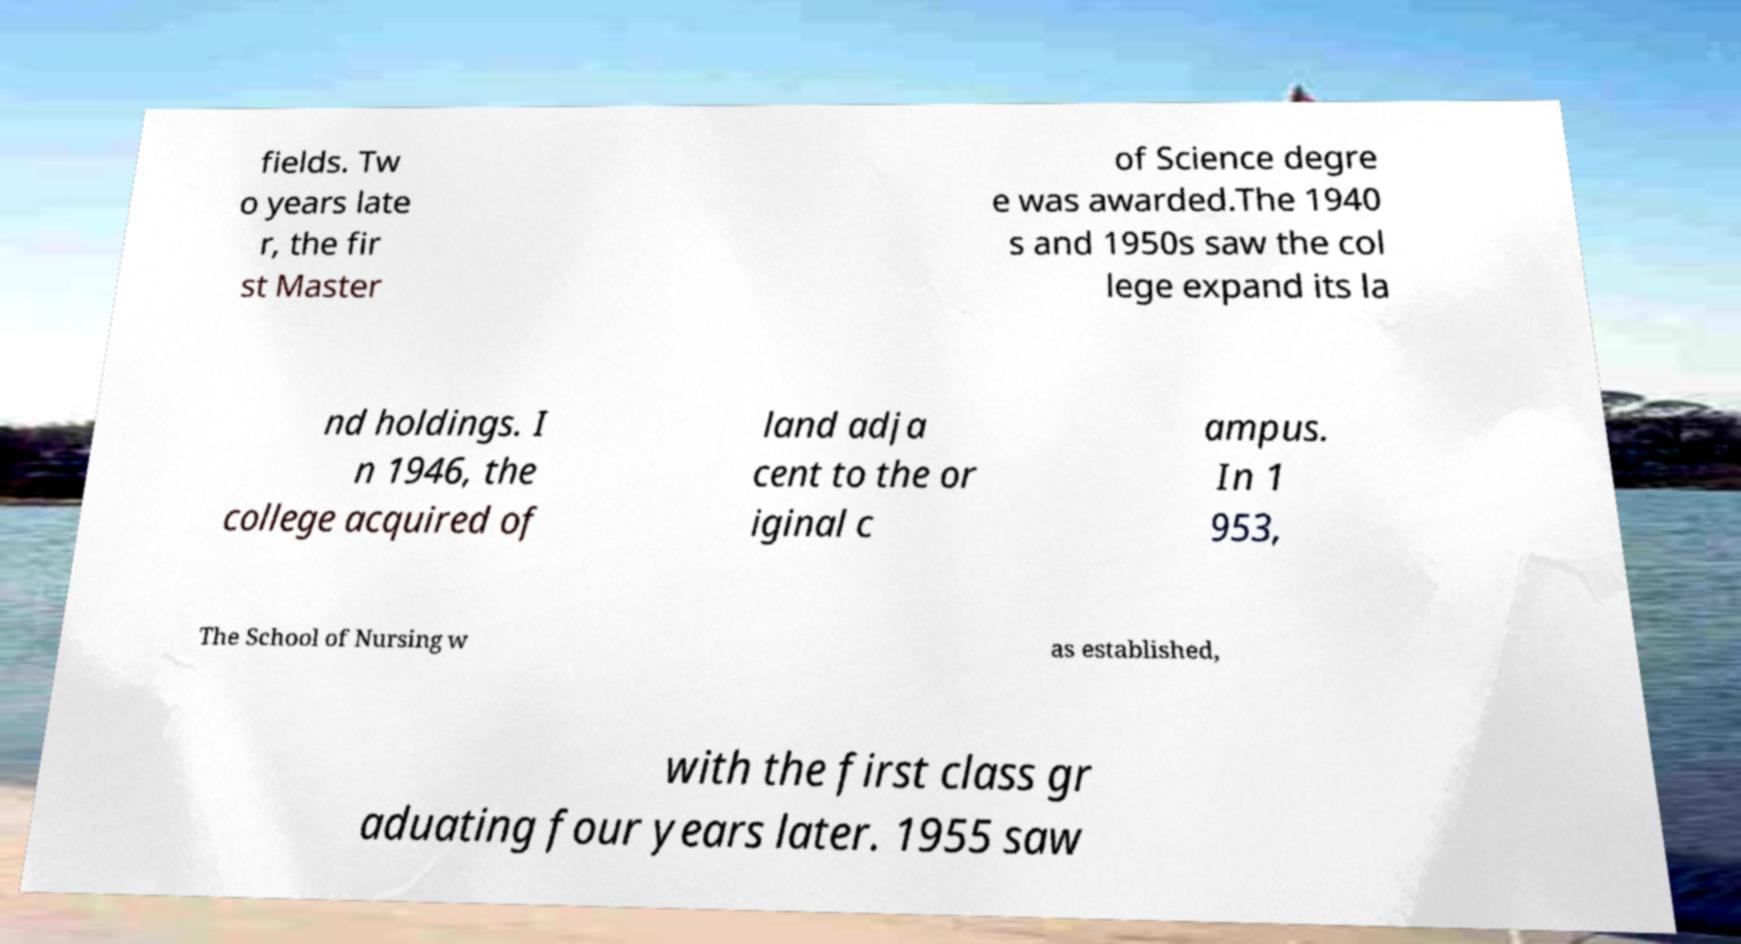What messages or text are displayed in this image? I need them in a readable, typed format. fields. Tw o years late r, the fir st Master of Science degre e was awarded.The 1940 s and 1950s saw the col lege expand its la nd holdings. I n 1946, the college acquired of land adja cent to the or iginal c ampus. In 1 953, The School of Nursing w as established, with the first class gr aduating four years later. 1955 saw 